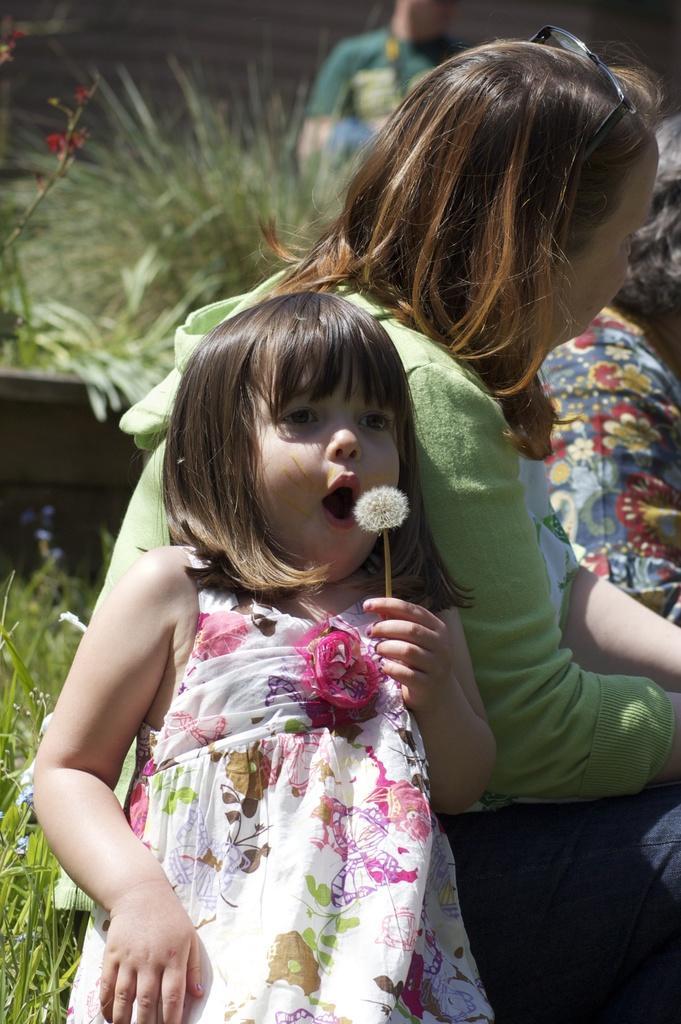Describe this image in one or two sentences. In this image I can see few people. In front the person is wearing white and pink color dress and holding some object and I can also see the person sitting. In the background I can see few plants in green color. 